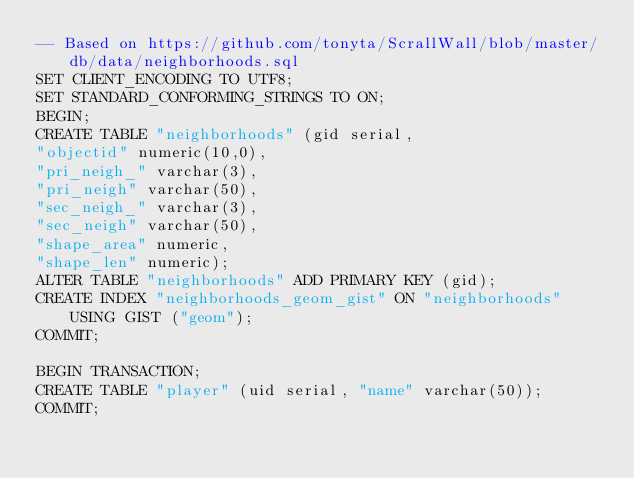Convert code to text. <code><loc_0><loc_0><loc_500><loc_500><_SQL_>-- Based on https://github.com/tonyta/ScrallWall/blob/master/db/data/neighborhoods.sql
SET CLIENT_ENCODING TO UTF8;
SET STANDARD_CONFORMING_STRINGS TO ON;
BEGIN;
CREATE TABLE "neighborhoods" (gid serial,
"objectid" numeric(10,0),
"pri_neigh_" varchar(3),
"pri_neigh" varchar(50),
"sec_neigh_" varchar(3),
"sec_neigh" varchar(50),
"shape_area" numeric,
"shape_len" numeric);
ALTER TABLE "neighborhoods" ADD PRIMARY KEY (gid);
CREATE INDEX "neighborhoods_geom_gist" ON "neighborhoods" USING GIST ("geom");
COMMIT;

BEGIN TRANSACTION;
CREATE TABLE "player" (uid serial, "name" varchar(50));
COMMIT;
</code> 